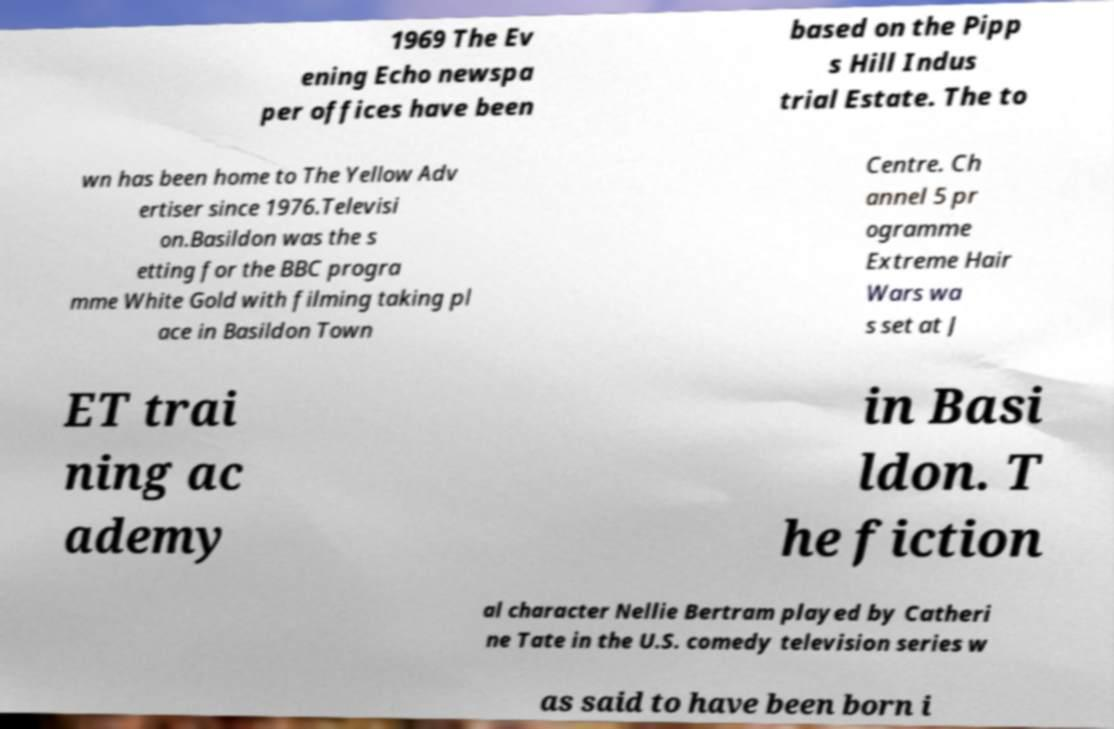Please identify and transcribe the text found in this image. 1969 The Ev ening Echo newspa per offices have been based on the Pipp s Hill Indus trial Estate. The to wn has been home to The Yellow Adv ertiser since 1976.Televisi on.Basildon was the s etting for the BBC progra mme White Gold with filming taking pl ace in Basildon Town Centre. Ch annel 5 pr ogramme Extreme Hair Wars wa s set at J ET trai ning ac ademy in Basi ldon. T he fiction al character Nellie Bertram played by Catheri ne Tate in the U.S. comedy television series w as said to have been born i 